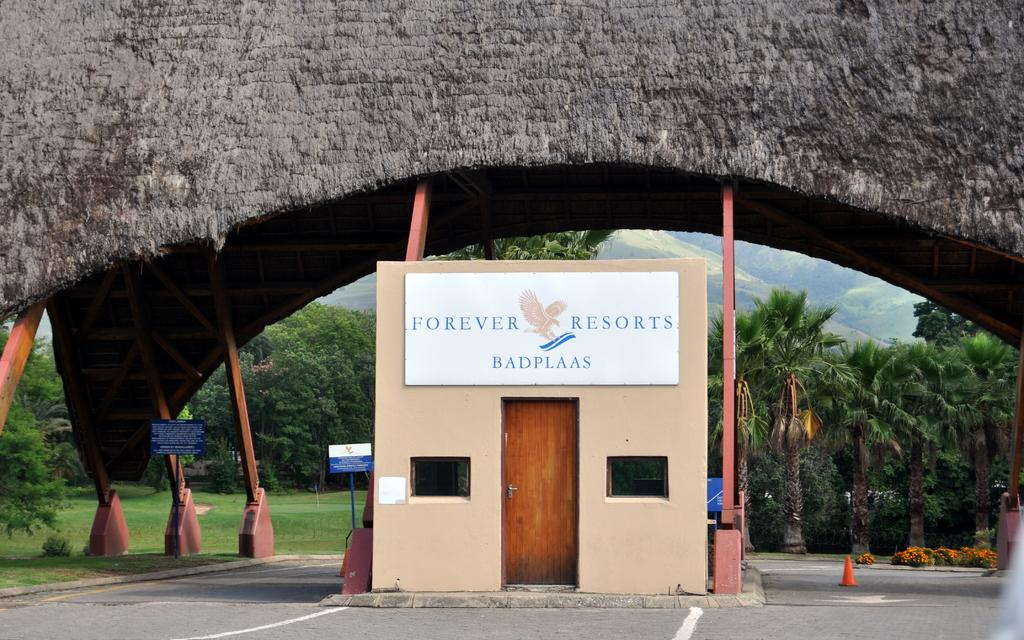What type of structure is present in the image? There is a building in the image. What feature of the building is visible? There is a window and a door in the image. What can be seen in the background of the image? There is a bridge, trees, and mountains visible in the background. What type of shoes can be seen hanging from the bridge in the image? There are no shoes visible in the image, and the bridge is not mentioned as having any shoes hanging from it. 